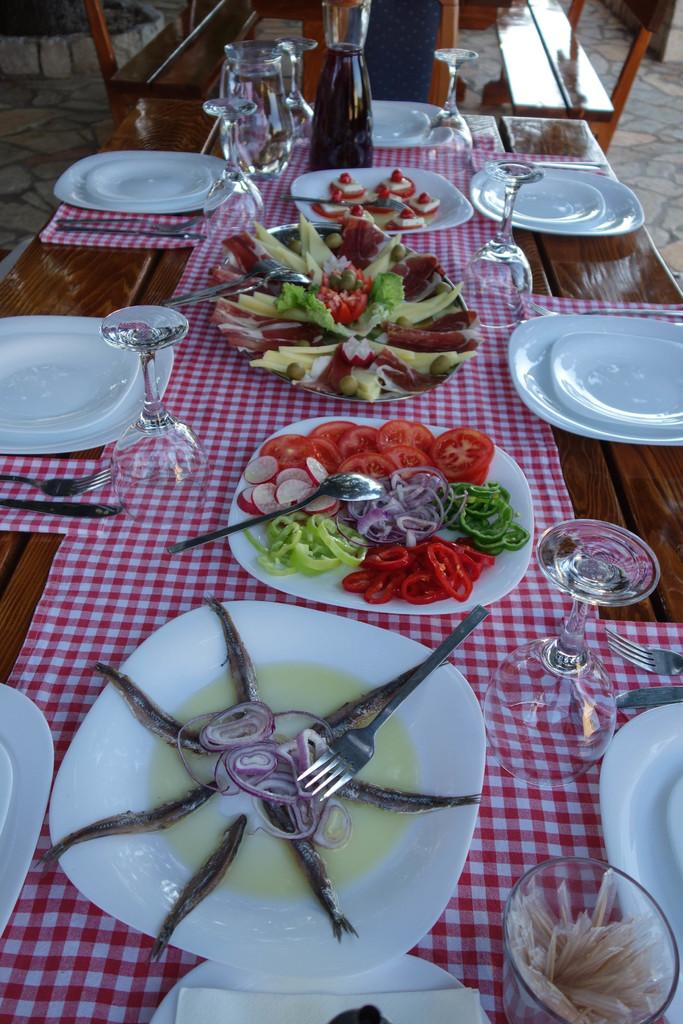What piece of furniture is present in the image? There is a table in the image. What items are placed on the table? There are plates, food, spoons, glasses, and mugs on the table. What type of utensils can be seen on the table? Spoons are visible on the table. What type of beverage containers are on the table? Glasses and mugs are on the table. What type of crayon is being used to draw on the table in the image? There is no crayon or drawing activity present in the image. What type of flowers are on the table in the image? There are no flowers present in the image; it only features a table with plates, food, spoons, glasses, and mugs. 